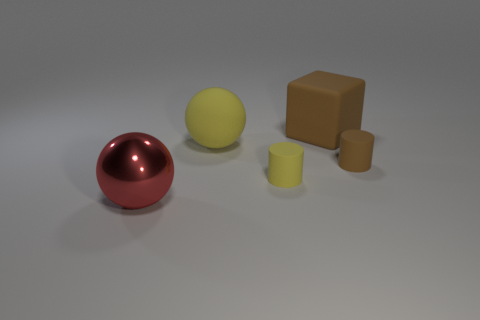Are there any other things that are the same shape as the big brown thing?
Provide a short and direct response. No. Are there more big yellow balls that are to the right of the big brown block than tiny purple shiny cylinders?
Your answer should be compact. No. How many big blocks are left of the tiny yellow rubber cylinder that is left of the brown matte thing that is in front of the block?
Provide a short and direct response. 0. There is a large object that is in front of the large brown matte object and behind the shiny thing; what is its material?
Make the answer very short. Rubber. The large matte ball has what color?
Ensure brevity in your answer.  Yellow. Is the number of large brown matte cubes that are in front of the big red object greater than the number of yellow matte things in front of the tiny yellow cylinder?
Ensure brevity in your answer.  No. There is a tiny matte object to the left of the block; what color is it?
Keep it short and to the point. Yellow. Does the ball behind the big red metallic sphere have the same size as the cylinder that is to the right of the yellow cylinder?
Ensure brevity in your answer.  No. What number of objects are either big objects or brown things?
Ensure brevity in your answer.  4. There is a small cylinder to the left of the small matte cylinder right of the big matte block; what is it made of?
Provide a succinct answer. Rubber. 